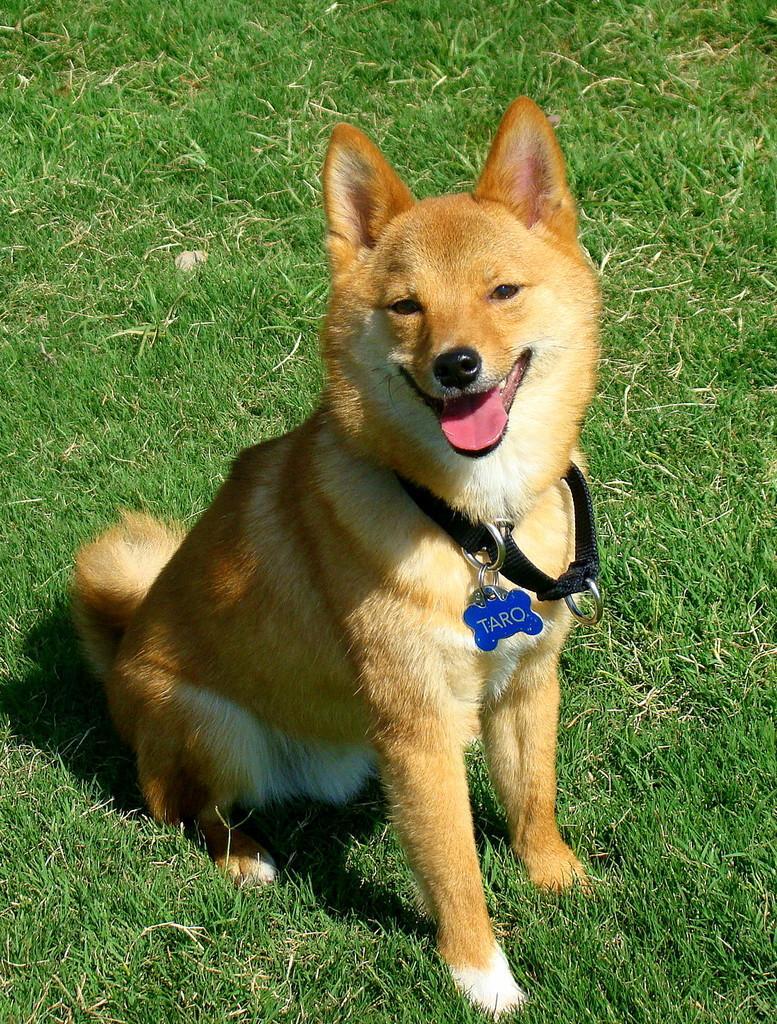Describe this image in one or two sentences. In this image, we can see a dog is sitting on the grass and watching. There is a belt with locket on the neck of a dog. 